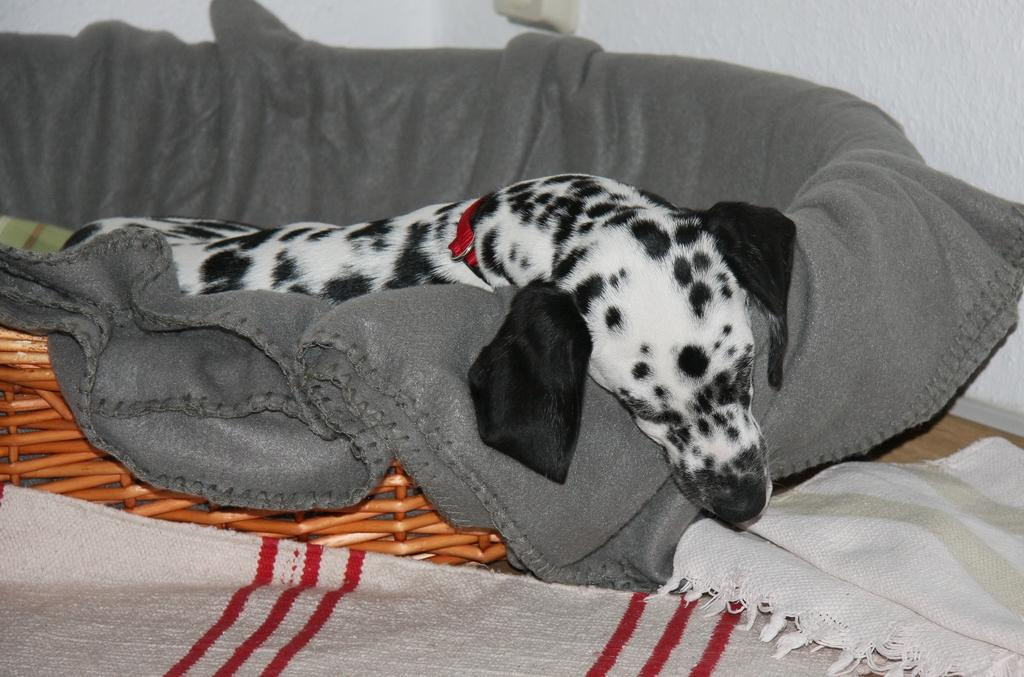What animal can be seen in the image? There is a dog in the image. What is the dog laying on? The dog is laying on a grey cloth. Are there any other clothes visible in the image? Yes, there are two other clothes in front of the dog. What can be seen in the background of the image? There is a wall in the background of the image. What type of linen is being used topped by the dog in the image? There is no linen present in the image, and the dog is laying on a grey cloth, not topping it. 